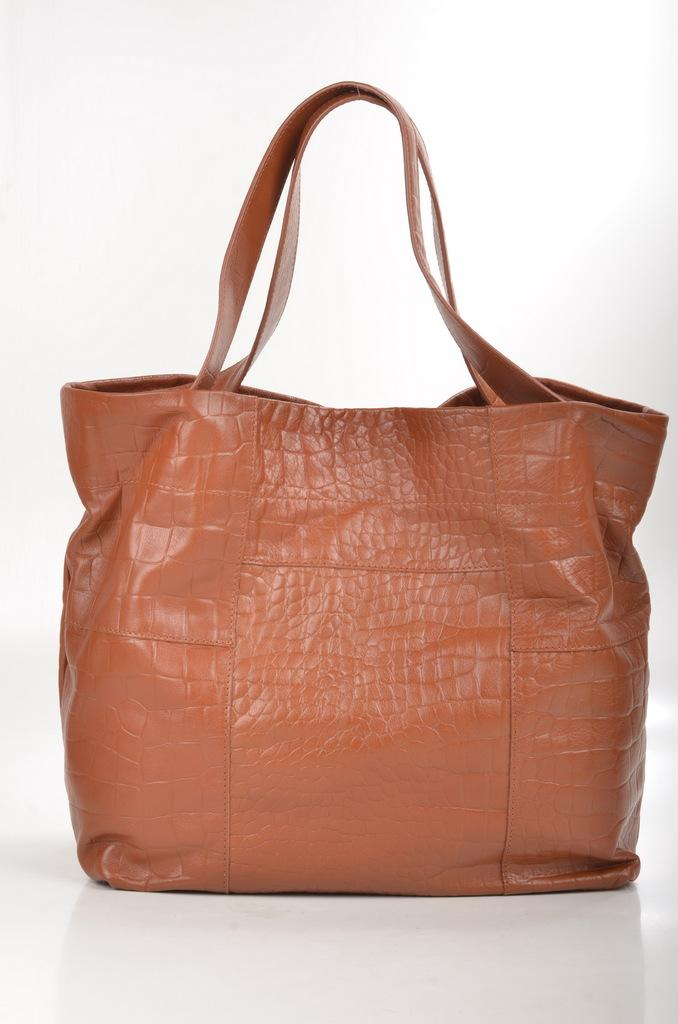What object can be seen in the image? There is a bag in the image. What invention is being celebrated during the holiday depicted in the image? There is no holiday or invention depicted in the image, as it only features a bag. 